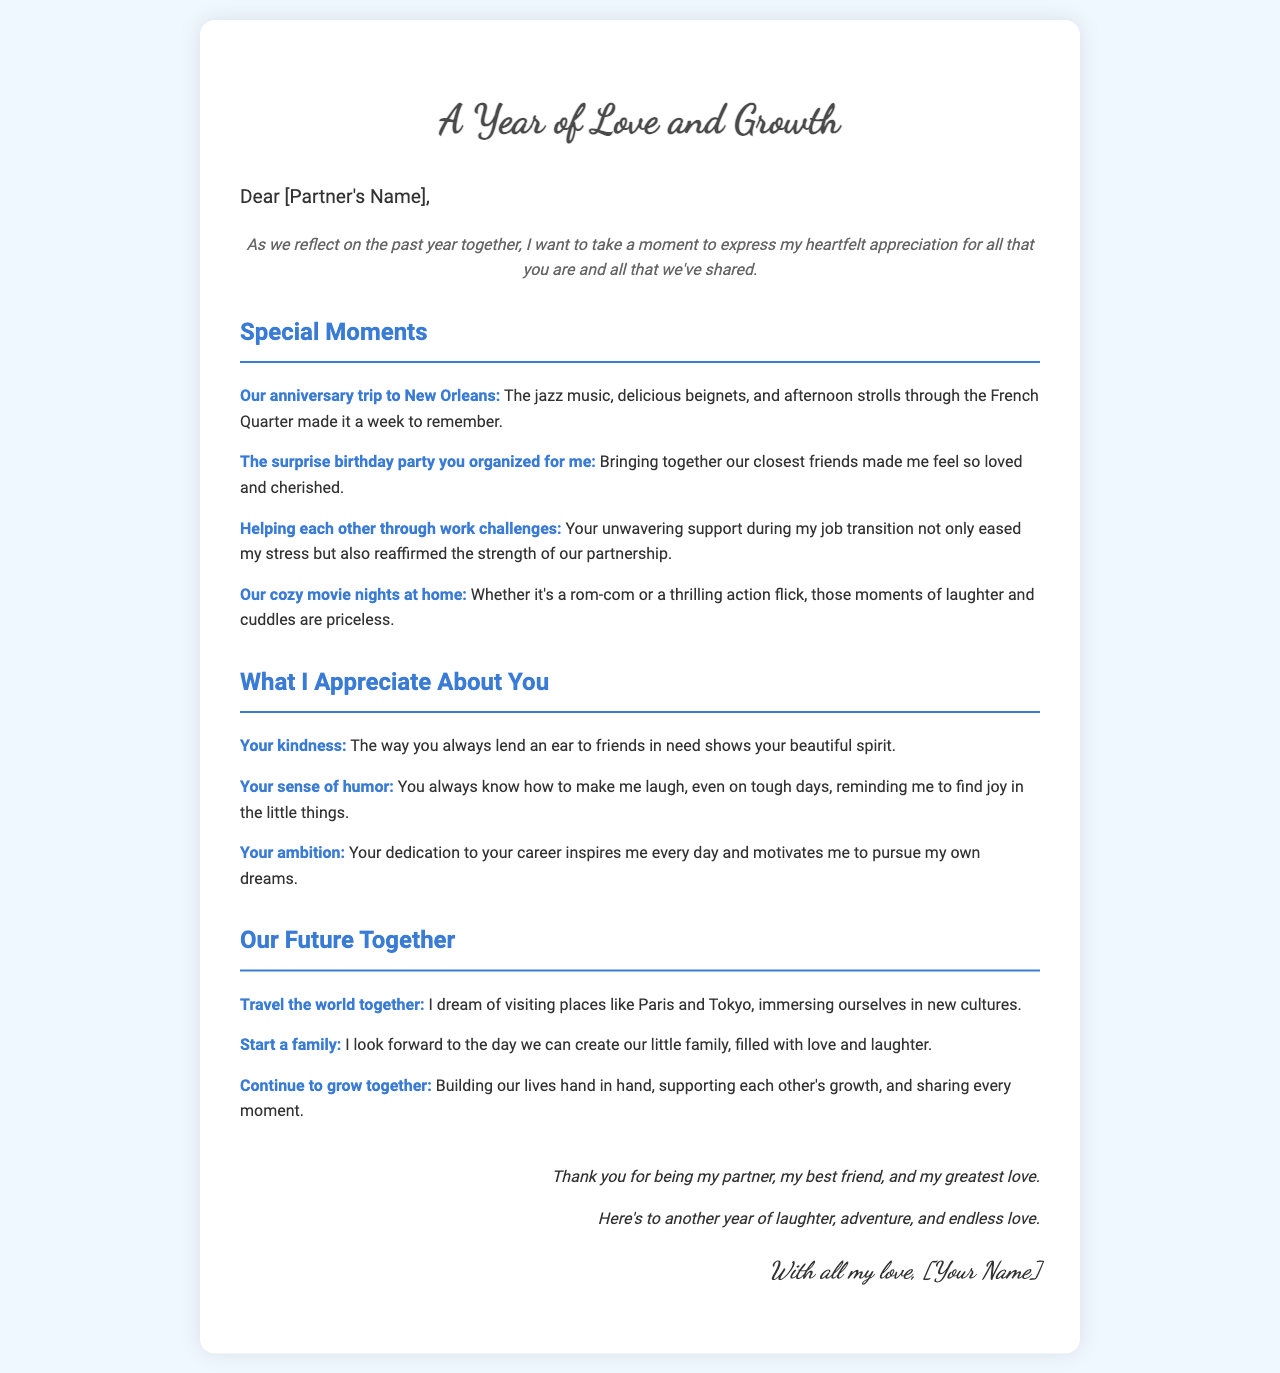what is the title of the letter? The title of the letter is presented prominently at the top of the document.
Answer: A Year of Love and Growth who is the letter addressed to? The letter begins with a greeting that specifies who it is written for.
Answer: [Partner's Name] name one special moment highlighted in the letter. The letter lists several special moments shared over the past year.
Answer: Our anniversary trip to New Orleans what quality of the partner is appreciated in the letter? The letter lists qualities of the partner that are appreciated by the writer.
Answer: Your kindness which future aspiration involves traveling? The letter expresses future aspirations that include plans for traveling together.
Answer: Travel the world together how many special moments are listed in the letter? The letter includes a specific number of points under the special moments section.
Answer: four what does the writer look forward to starting together? The letter mentions a key aspiration related to family planning.
Answer: Start a family what tone does the closing of the letter convey? The letter's closing expresses a specific sentiment towards the partner.
Answer: Love 